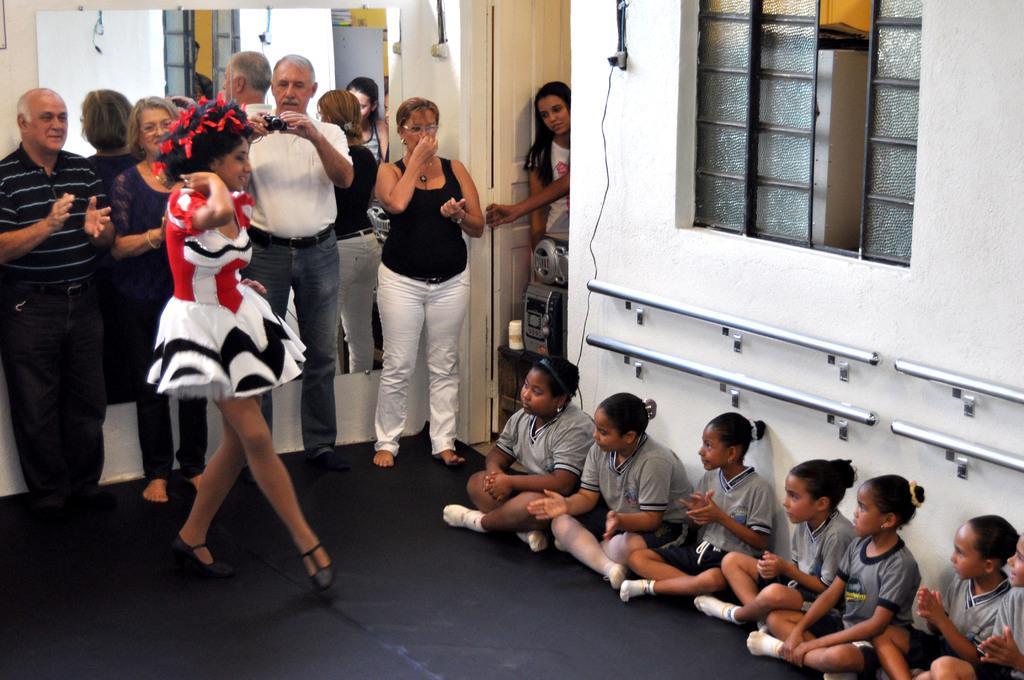Describe this image in one or two sentences. In this picture I can see there is a woman dancing at left side, there are a few people standing behind her, among them a man is clicking images. There are few children sitting at the right side, there is a window to the right. I can see there is a door on the left side, there is a woman as a speaker placed to the left side. 